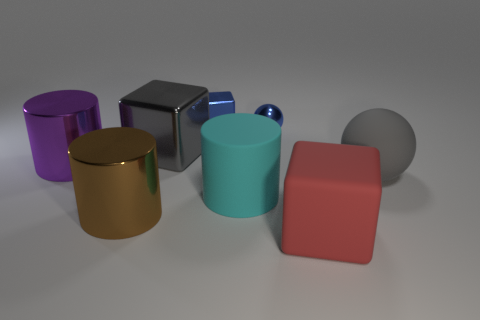Subtract all big brown cylinders. How many cylinders are left? 2 Add 2 large purple metallic cylinders. How many objects exist? 10 Subtract all balls. How many objects are left? 6 Subtract all small blue objects. Subtract all large cyan matte things. How many objects are left? 5 Add 2 metallic cubes. How many metallic cubes are left? 4 Add 5 big matte balls. How many big matte balls exist? 6 Subtract 0 red balls. How many objects are left? 8 